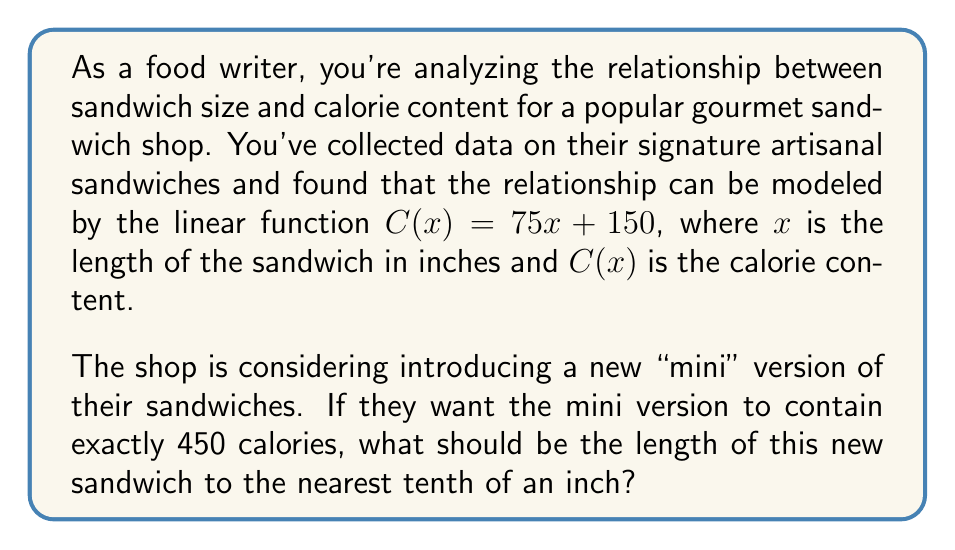Can you answer this question? To solve this problem, we need to use the given linear function and work backwards to find the sandwich length that corresponds to 450 calories.

1) The linear function is given as:
   $C(x) = 75x + 150$

2) We want to find $x$ when $C(x) = 450$. So, we set up the equation:
   $450 = 75x + 150$

3) Subtract 150 from both sides:
   $300 = 75x$

4) Divide both sides by 75:
   $\frac{300}{75} = x$

5) Simplify:
   $4 = x$

6) Therefore, the exact length of the sandwich should be 4 inches.

7) Since the question asks for the answer to the nearest tenth of an inch, and 4 is already expressed to the nearest tenth, our final answer is 4.0 inches.
Answer: 4.0 inches 